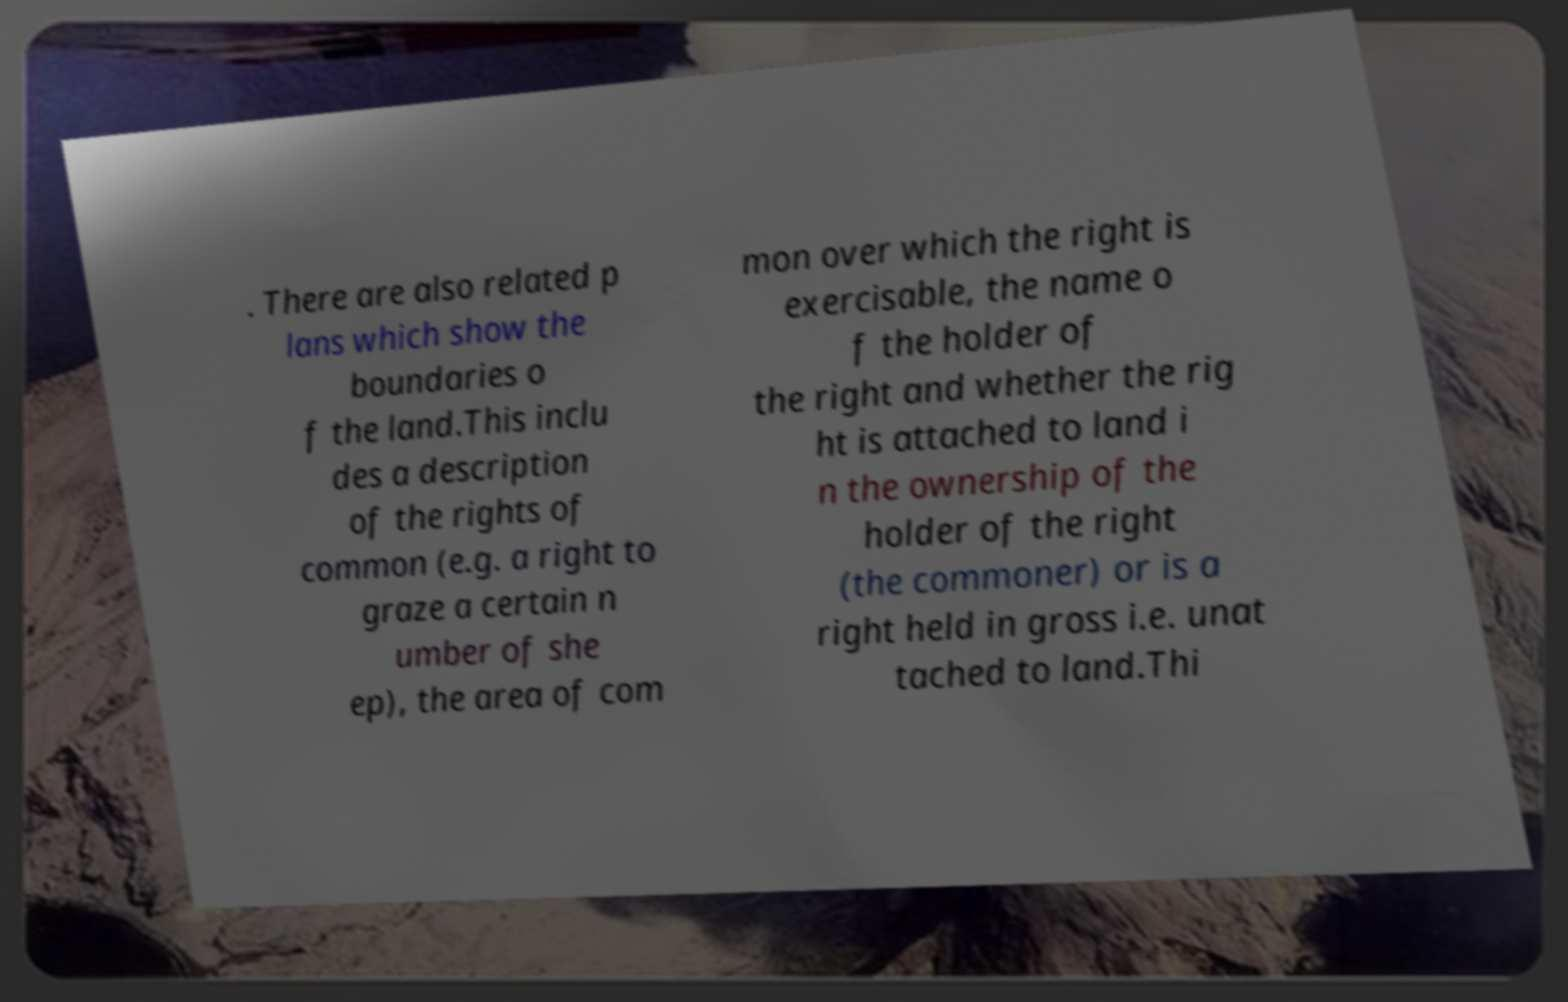What messages or text are displayed in this image? I need them in a readable, typed format. . There are also related p lans which show the boundaries o f the land.This inclu des a description of the rights of common (e.g. a right to graze a certain n umber of she ep), the area of com mon over which the right is exercisable, the name o f the holder of the right and whether the rig ht is attached to land i n the ownership of the holder of the right (the commoner) or is a right held in gross i.e. unat tached to land.Thi 